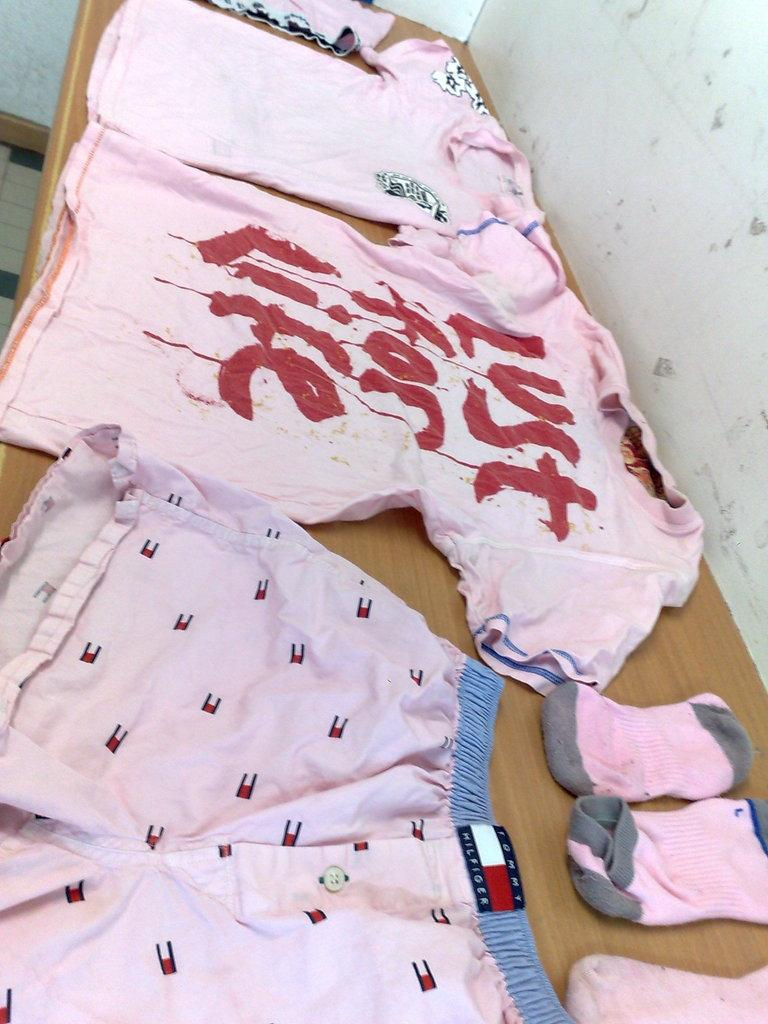Where was the image taken? The image was taken indoors. What can be seen in the background of the image? There is a wall in the background of the image. What is located at the bottom of the image? There is a table at the bottom of the image. What type of clothing items are on the table? There are T-shirts, shorts, and socks on the table. What type of ship can be seen sailing in the background of the image? There is no ship visible in the background of the image; it is a wall. How much does the quarter cost in the image? There is no mention of a quarter or any currency in the image. 